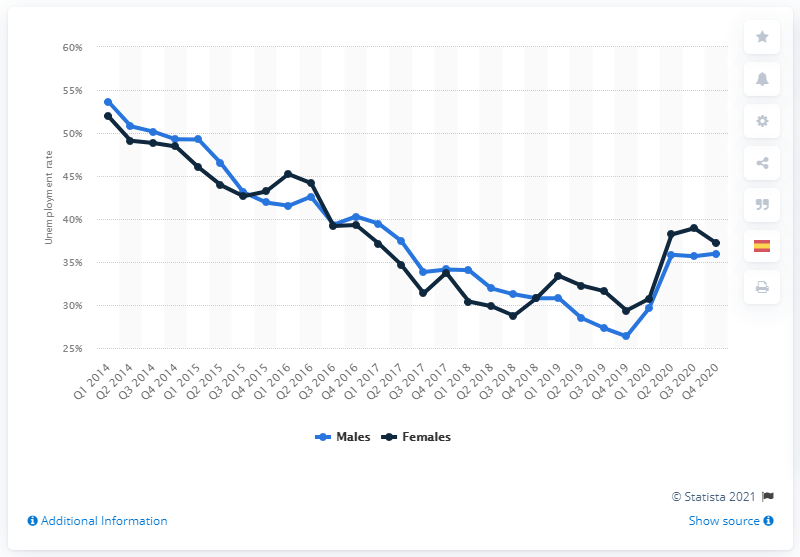Give some essential details in this illustration. The highest unemployment rate for both genders in the first quarter of 2014 was 50.16%. In the fourth quarter of 2020, the unemployment rate for females between the ages of 20 and 24 was 37.16%. According to data from the fourth quarter of 2020, the unemployment rate among male professionals was 35.98%. 